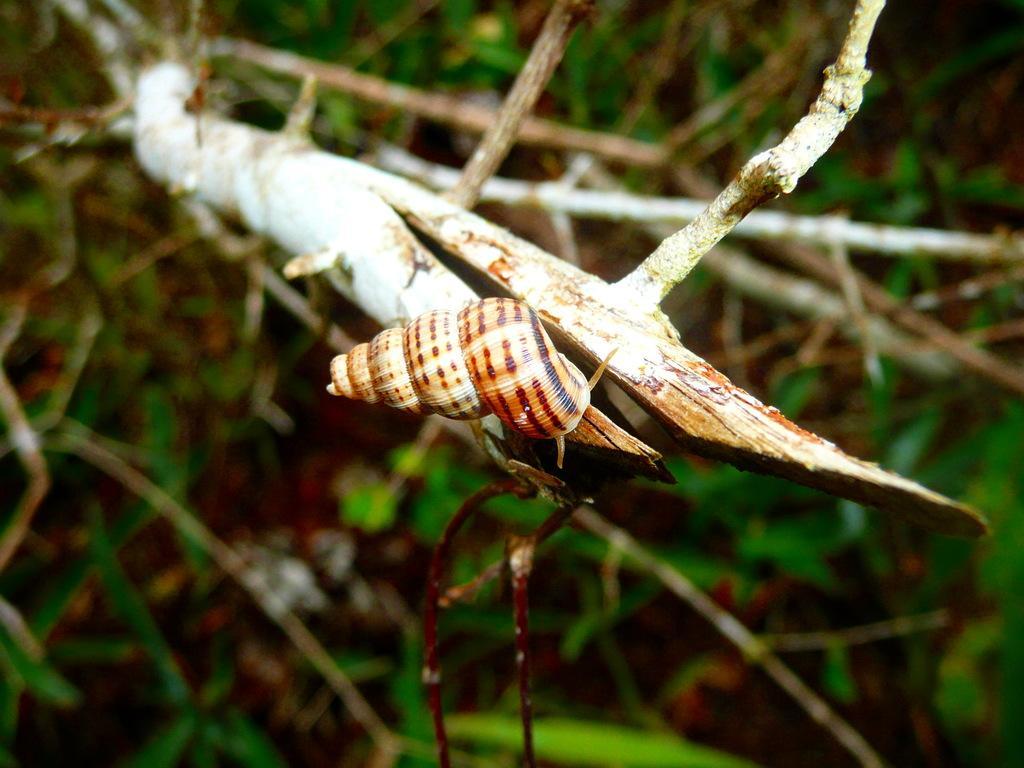In one or two sentences, can you explain what this image depicts? In this image, we can see a snail on the wooden stick. Background we can see the blur view. 